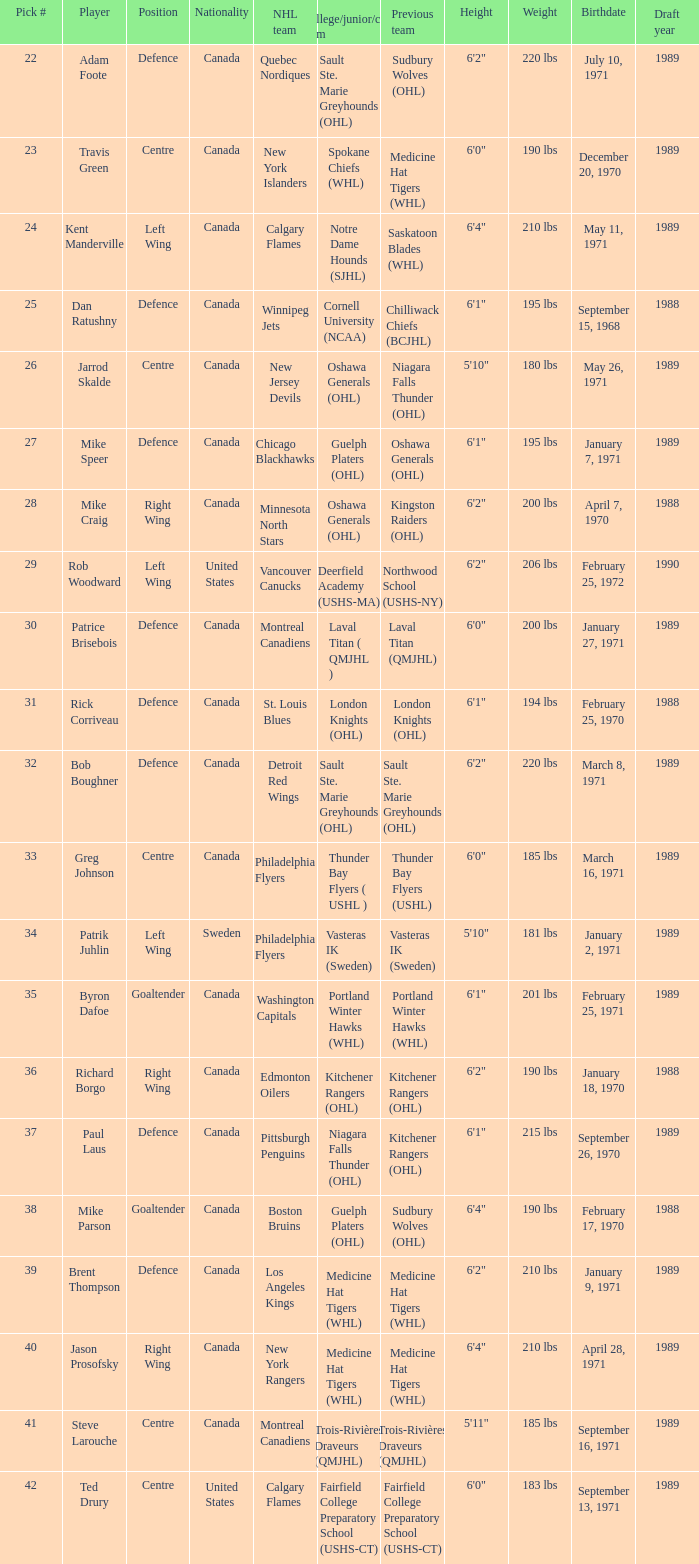What NHL team picked richard borgo? Edmonton Oilers. Would you mind parsing the complete table? {'header': ['Pick #', 'Player', 'Position', 'Nationality', 'NHL team', 'College/junior/club team', 'Previous team', 'Height', 'Weight', 'Birthdate', 'Draft year'], 'rows': [['22', 'Adam Foote', 'Defence', 'Canada', 'Quebec Nordiques', 'Sault Ste. Marie Greyhounds (OHL)', 'Sudbury Wolves (OHL)', '6\'2"', '220 lbs', 'July 10, 1971', '1989'], ['23', 'Travis Green', 'Centre', 'Canada', 'New York Islanders', 'Spokane Chiefs (WHL)', 'Medicine Hat Tigers (WHL)', '6\'0"', '190 lbs', 'December 20, 1970', '1989'], ['24', 'Kent Manderville', 'Left Wing', 'Canada', 'Calgary Flames', 'Notre Dame Hounds (SJHL)', 'Saskatoon Blades (WHL)', '6\'4"', '210 lbs', 'May 11, 1971', '1989'], ['25', 'Dan Ratushny', 'Defence', 'Canada', 'Winnipeg Jets', 'Cornell University (NCAA)', 'Chilliwack Chiefs (BCJHL)', '6\'1"', '195 lbs', 'September 15, 1968', '1988'], ['26', 'Jarrod Skalde', 'Centre', 'Canada', 'New Jersey Devils', 'Oshawa Generals (OHL)', 'Niagara Falls Thunder (OHL)', '5\'10"', '180 lbs', 'May 26, 1971', '1989'], ['27', 'Mike Speer', 'Defence', 'Canada', 'Chicago Blackhawks', 'Guelph Platers (OHL)', 'Oshawa Generals (OHL)', '6\'1"', '195 lbs', 'January 7, 1971', '1989'], ['28', 'Mike Craig', 'Right Wing', 'Canada', 'Minnesota North Stars', 'Oshawa Generals (OHL)', 'Kingston Raiders (OHL)', '6\'2"', '200 lbs', 'April 7, 1970', '1988'], ['29', 'Rob Woodward', 'Left Wing', 'United States', 'Vancouver Canucks', 'Deerfield Academy (USHS-MA)', 'Northwood School (USHS-NY)', '6\'2"', '206 lbs', 'February 25, 1972', '1990'], ['30', 'Patrice Brisebois', 'Defence', 'Canada', 'Montreal Canadiens', 'Laval Titan ( QMJHL )', 'Laval Titan (QMJHL)', '6\'0"', '200 lbs', 'January 27, 1971', '1989'], ['31', 'Rick Corriveau', 'Defence', 'Canada', 'St. Louis Blues', 'London Knights (OHL)', 'London Knights (OHL)', '6\'1"', '194 lbs', 'February 25, 1970', '1988'], ['32', 'Bob Boughner', 'Defence', 'Canada', 'Detroit Red Wings', 'Sault Ste. Marie Greyhounds (OHL)', 'Sault Ste. Marie Greyhounds (OHL)', '6\'2"', '220 lbs', 'March 8, 1971', '1989'], ['33', 'Greg Johnson', 'Centre', 'Canada', 'Philadelphia Flyers', 'Thunder Bay Flyers ( USHL )', 'Thunder Bay Flyers (USHL)', '6\'0"', '185 lbs', 'March 16, 1971', '1989'], ['34', 'Patrik Juhlin', 'Left Wing', 'Sweden', 'Philadelphia Flyers', 'Vasteras IK (Sweden)', 'Vasteras IK (Sweden)', '5\'10"', '181 lbs', 'January 2, 1971', '1989'], ['35', 'Byron Dafoe', 'Goaltender', 'Canada', 'Washington Capitals', 'Portland Winter Hawks (WHL)', 'Portland Winter Hawks (WHL)', '6\'1"', '201 lbs', 'February 25, 1971', '1989'], ['36', 'Richard Borgo', 'Right Wing', 'Canada', 'Edmonton Oilers', 'Kitchener Rangers (OHL)', 'Kitchener Rangers (OHL)', '6\'2"', '190 lbs', 'January 18, 1970', '1988'], ['37', 'Paul Laus', 'Defence', 'Canada', 'Pittsburgh Penguins', 'Niagara Falls Thunder (OHL)', 'Kitchener Rangers (OHL)', '6\'1"', '215 lbs', 'September 26, 1970', '1989'], ['38', 'Mike Parson', 'Goaltender', 'Canada', 'Boston Bruins', 'Guelph Platers (OHL)', 'Sudbury Wolves (OHL)', '6\'4"', '190 lbs', 'February 17, 1970', '1988'], ['39', 'Brent Thompson', 'Defence', 'Canada', 'Los Angeles Kings', 'Medicine Hat Tigers (WHL)', 'Medicine Hat Tigers (WHL)', '6\'2"', '210 lbs', 'January 9, 1971', '1989'], ['40', 'Jason Prosofsky', 'Right Wing', 'Canada', 'New York Rangers', 'Medicine Hat Tigers (WHL)', 'Medicine Hat Tigers (WHL)', '6\'4"', '210 lbs', 'April 28, 1971', '1989'], ['41', 'Steve Larouche', 'Centre', 'Canada', 'Montreal Canadiens', 'Trois-Rivières Draveurs (QMJHL)', 'Trois-Rivières Draveurs (QMJHL)', '5\'11"', '185 lbs', 'September 16, 1971', '1989'], ['42', 'Ted Drury', 'Centre', 'United States', 'Calgary Flames', 'Fairfield College Preparatory School (USHS-CT)', 'Fairfield College Preparatory School (USHS-CT)', '6\'0"', '183 lbs', 'September 13, 1971', '1989']]} 